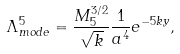<formula> <loc_0><loc_0><loc_500><loc_500>\Lambda ^ { 5 } _ { m o d e } = \frac { M ^ { 3 / 2 } _ { 5 } } { \sqrt { k } } \frac { 1 } { a ^ { 4 } } e ^ { - 5 k y } ,</formula> 